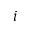Convert formula to latex. <formula><loc_0><loc_0><loc_500><loc_500>i</formula> 